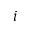Convert formula to latex. <formula><loc_0><loc_0><loc_500><loc_500>i</formula> 